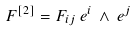Convert formula to latex. <formula><loc_0><loc_0><loc_500><loc_500>F ^ { [ 2 ] } = F _ { i j } \, e ^ { i } \, \wedge \, e ^ { j }</formula> 